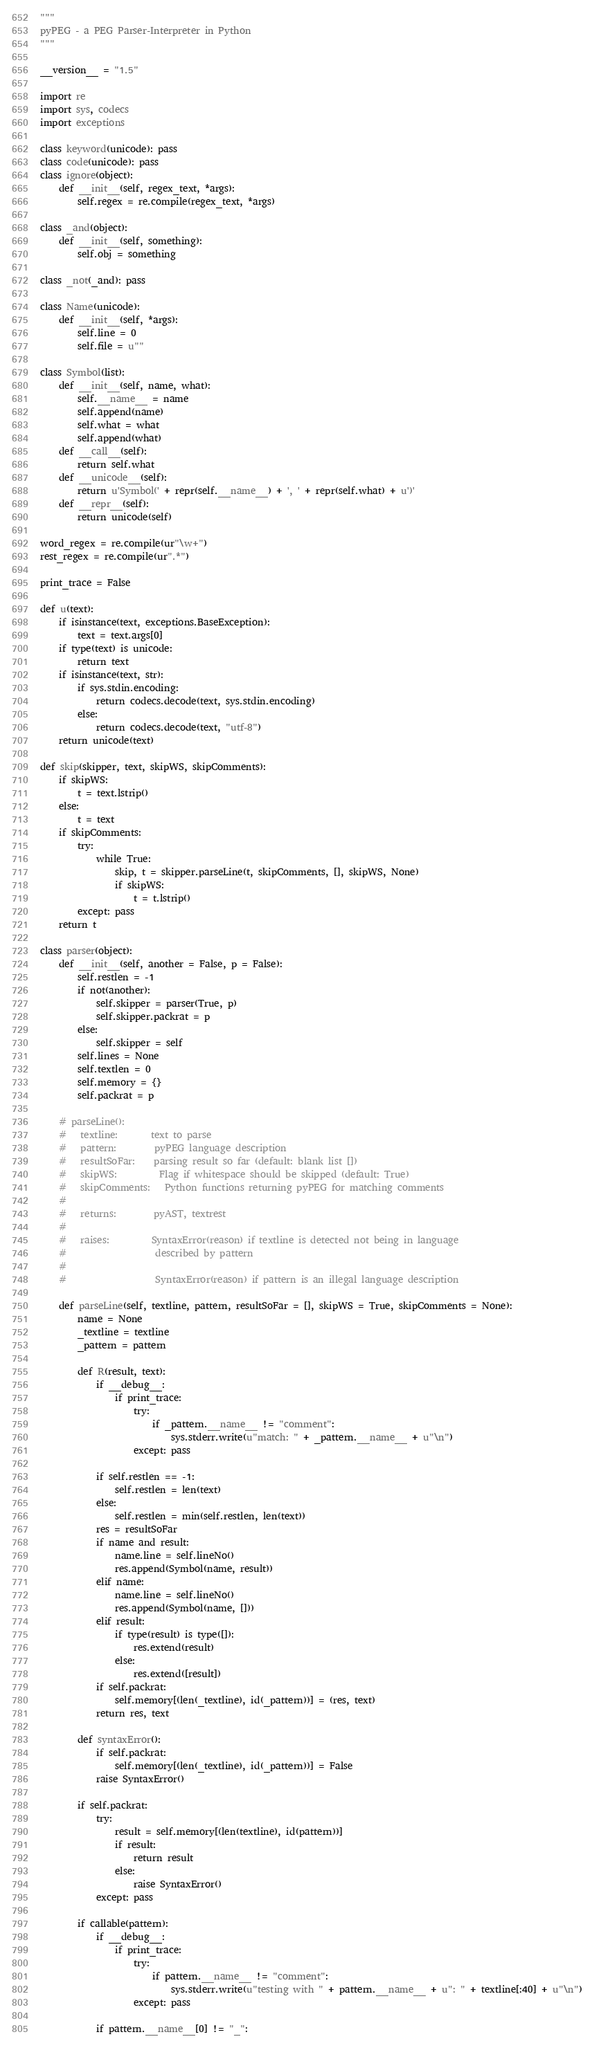Convert code to text. <code><loc_0><loc_0><loc_500><loc_500><_Python_>"""
pyPEG - a PEG Parser-Interpreter in Python
"""

__version__ = "1.5"

import re
import sys, codecs
import exceptions

class keyword(unicode): pass
class code(unicode): pass
class ignore(object):
    def __init__(self, regex_text, *args):
        self.regex = re.compile(regex_text, *args)

class _and(object):
    def __init__(self, something):
        self.obj = something

class _not(_and): pass

class Name(unicode):
    def __init__(self, *args):
        self.line = 0
        self.file = u""

class Symbol(list):
    def __init__(self, name, what):
        self.__name__ = name
        self.append(name)
        self.what = what
        self.append(what)
    def __call__(self):
        return self.what
    def __unicode__(self):
        return u'Symbol(' + repr(self.__name__) + ', ' + repr(self.what) + u')'
    def __repr__(self):
        return unicode(self)

word_regex = re.compile(ur"\w+")
rest_regex = re.compile(ur".*")

print_trace = False

def u(text):
    if isinstance(text, exceptions.BaseException):
        text = text.args[0]
    if type(text) is unicode:
        return text
    if isinstance(text, str):
        if sys.stdin.encoding:
            return codecs.decode(text, sys.stdin.encoding)
        else:
            return codecs.decode(text, "utf-8")
    return unicode(text)

def skip(skipper, text, skipWS, skipComments):
    if skipWS:
        t = text.lstrip()
    else:
        t = text
    if skipComments:
        try:
            while True:
                skip, t = skipper.parseLine(t, skipComments, [], skipWS, None)
                if skipWS:
                    t = t.lstrip()
        except: pass
    return t

class parser(object):
    def __init__(self, another = False, p = False):
        self.restlen = -1 
        if not(another):
            self.skipper = parser(True, p)
            self.skipper.packrat = p
        else:
            self.skipper = self
        self.lines = None
        self.textlen = 0
        self.memory = {}
        self.packrat = p

    # parseLine():
    #   textline:       text to parse
    #   pattern:        pyPEG language description
    #   resultSoFar:    parsing result so far (default: blank list [])
    #   skipWS:         Flag if whitespace should be skipped (default: True)
    #   skipComments:   Python functions returning pyPEG for matching comments
    #   
    #   returns:        pyAST, textrest
    #
    #   raises:         SyntaxError(reason) if textline is detected not being in language
    #                   described by pattern
    #
    #                   SyntaxError(reason) if pattern is an illegal language description

    def parseLine(self, textline, pattern, resultSoFar = [], skipWS = True, skipComments = None):
        name = None
        _textline = textline
        _pattern = pattern

        def R(result, text):
            if __debug__:
                if print_trace:
                    try:
                        if _pattern.__name__ != "comment":
                            sys.stderr.write(u"match: " + _pattern.__name__ + u"\n")
                    except: pass

            if self.restlen == -1:
                self.restlen = len(text)
            else:
                self.restlen = min(self.restlen, len(text))
            res = resultSoFar
            if name and result:
                name.line = self.lineNo()
                res.append(Symbol(name, result))
            elif name:
                name.line = self.lineNo()
                res.append(Symbol(name, []))
            elif result:
                if type(result) is type([]):
                    res.extend(result)
                else:
                    res.extend([result])
            if self.packrat:
                self.memory[(len(_textline), id(_pattern))] = (res, text)
            return res, text

        def syntaxError():
            if self.packrat:
                self.memory[(len(_textline), id(_pattern))] = False
            raise SyntaxError()

        if self.packrat:
            try:
                result = self.memory[(len(textline), id(pattern))]
                if result:
                    return result
                else:
                    raise SyntaxError()
            except: pass

        if callable(pattern):
            if __debug__:
                if print_trace:
                    try:
                        if pattern.__name__ != "comment":
                            sys.stderr.write(u"testing with " + pattern.__name__ + u": " + textline[:40] + u"\n")
                    except: pass

            if pattern.__name__[0] != "_":</code> 